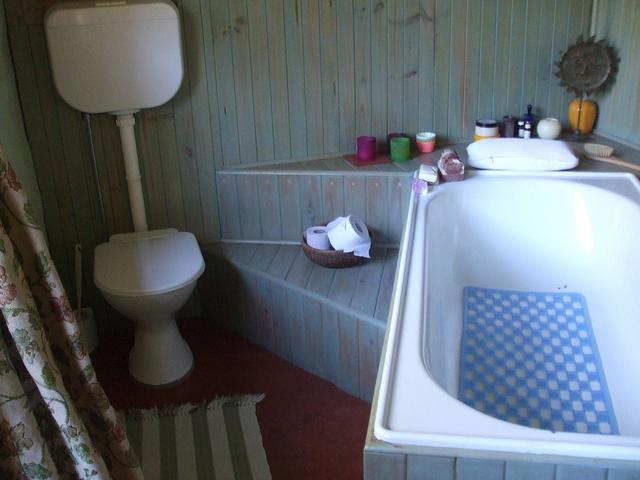What type of rolls are in the wicker basket? toilet paper 